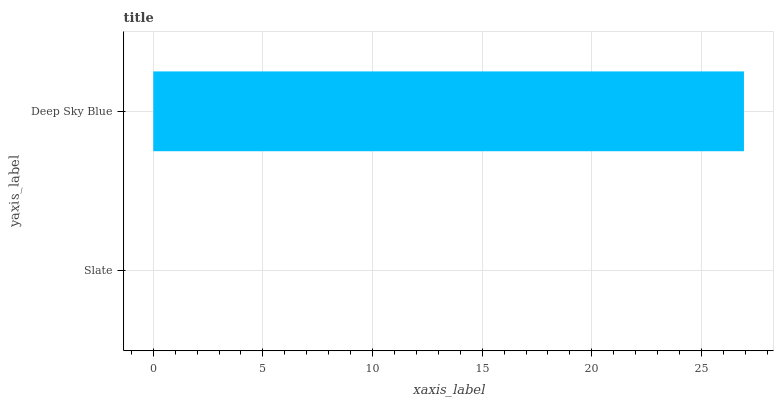Is Slate the minimum?
Answer yes or no. Yes. Is Deep Sky Blue the maximum?
Answer yes or no. Yes. Is Deep Sky Blue the minimum?
Answer yes or no. No. Is Deep Sky Blue greater than Slate?
Answer yes or no. Yes. Is Slate less than Deep Sky Blue?
Answer yes or no. Yes. Is Slate greater than Deep Sky Blue?
Answer yes or no. No. Is Deep Sky Blue less than Slate?
Answer yes or no. No. Is Deep Sky Blue the high median?
Answer yes or no. Yes. Is Slate the low median?
Answer yes or no. Yes. Is Slate the high median?
Answer yes or no. No. Is Deep Sky Blue the low median?
Answer yes or no. No. 